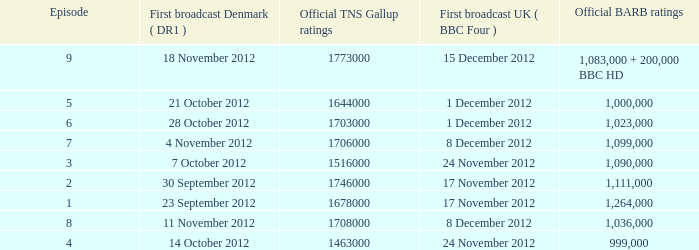What is the BARB ratings of episode 6? 1023000.0. 